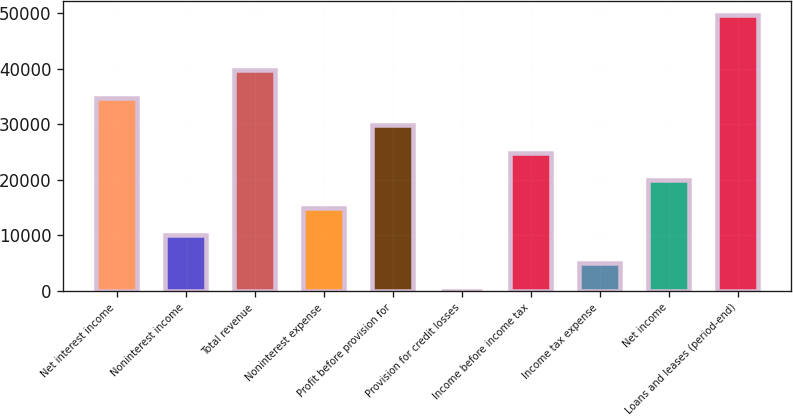Convert chart to OTSL. <chart><loc_0><loc_0><loc_500><loc_500><bar_chart><fcel>Net interest income<fcel>Noninterest income<fcel>Total revenue<fcel>Noninterest expense<fcel>Profit before provision for<fcel>Provision for credit losses<fcel>Income before income tax<fcel>Income tax expense<fcel>Net income<fcel>Loans and leases (period-end)<nl><fcel>34828.6<fcel>9964.6<fcel>39801.4<fcel>14937.4<fcel>29855.8<fcel>19<fcel>24883<fcel>4991.8<fcel>19910.2<fcel>49747<nl></chart> 